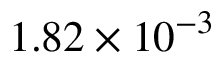<formula> <loc_0><loc_0><loc_500><loc_500>1 . 8 2 \times { { 1 0 } ^ { - 3 } }</formula> 